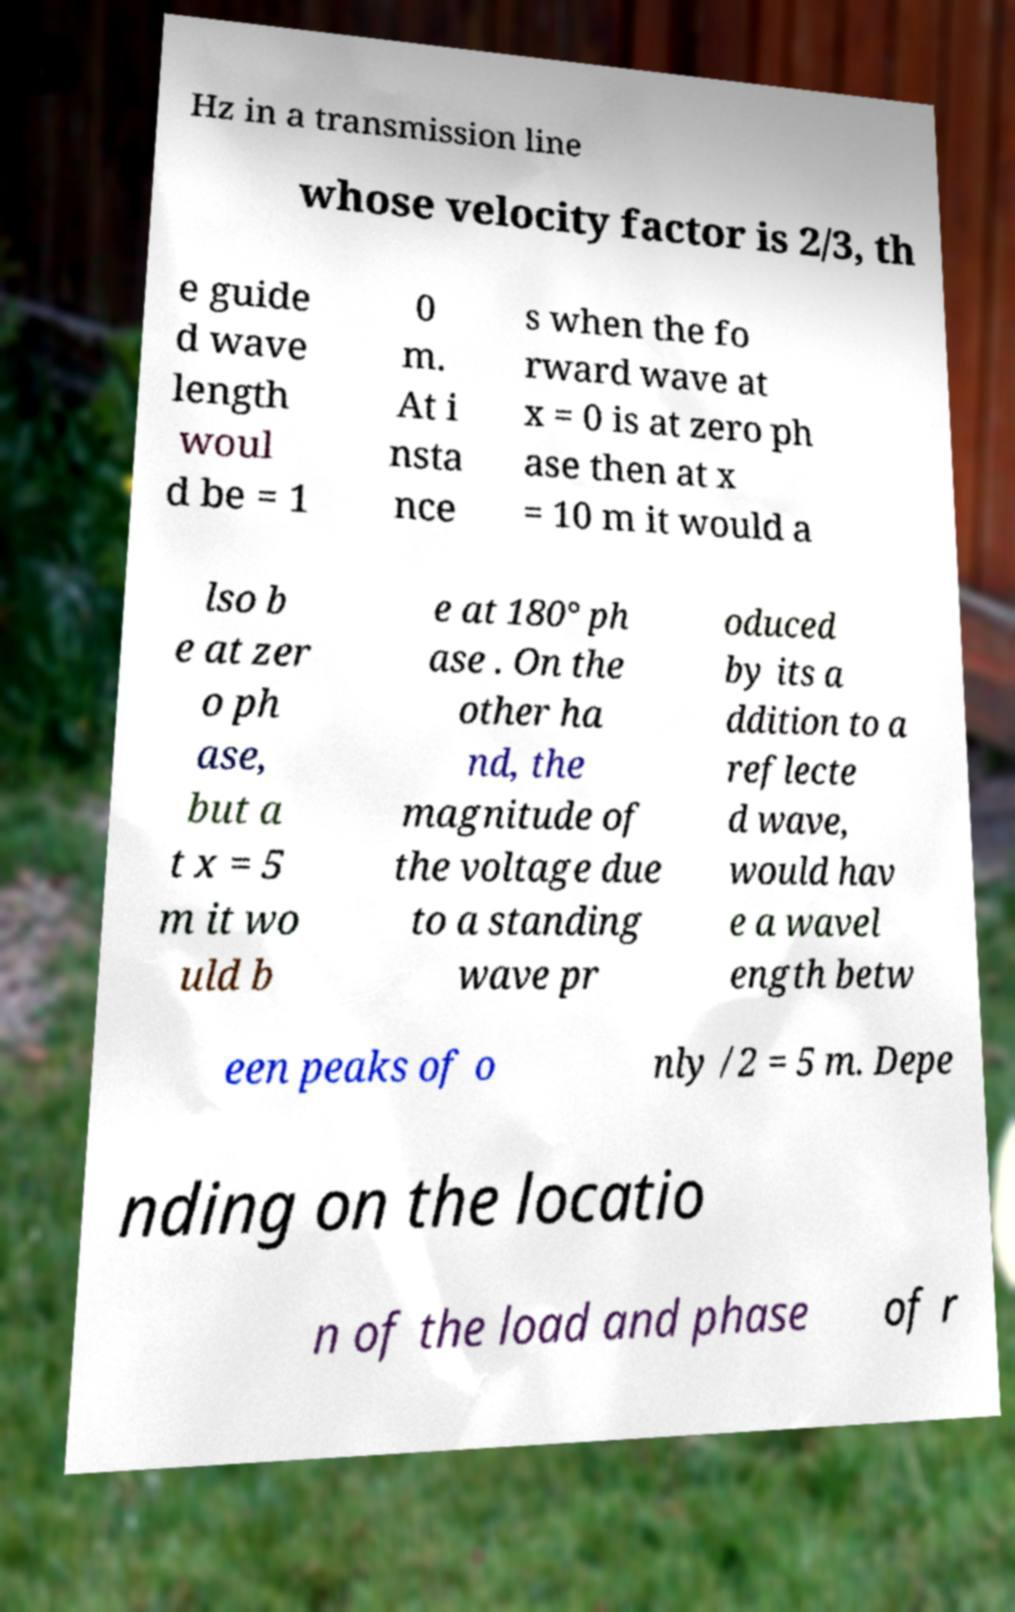There's text embedded in this image that I need extracted. Can you transcribe it verbatim? Hz in a transmission line whose velocity factor is 2/3, th e guide d wave length woul d be = 1 0 m. At i nsta nce s when the fo rward wave at x = 0 is at zero ph ase then at x = 10 m it would a lso b e at zer o ph ase, but a t x = 5 m it wo uld b e at 180° ph ase . On the other ha nd, the magnitude of the voltage due to a standing wave pr oduced by its a ddition to a reflecte d wave, would hav e a wavel ength betw een peaks of o nly /2 = 5 m. Depe nding on the locatio n of the load and phase of r 